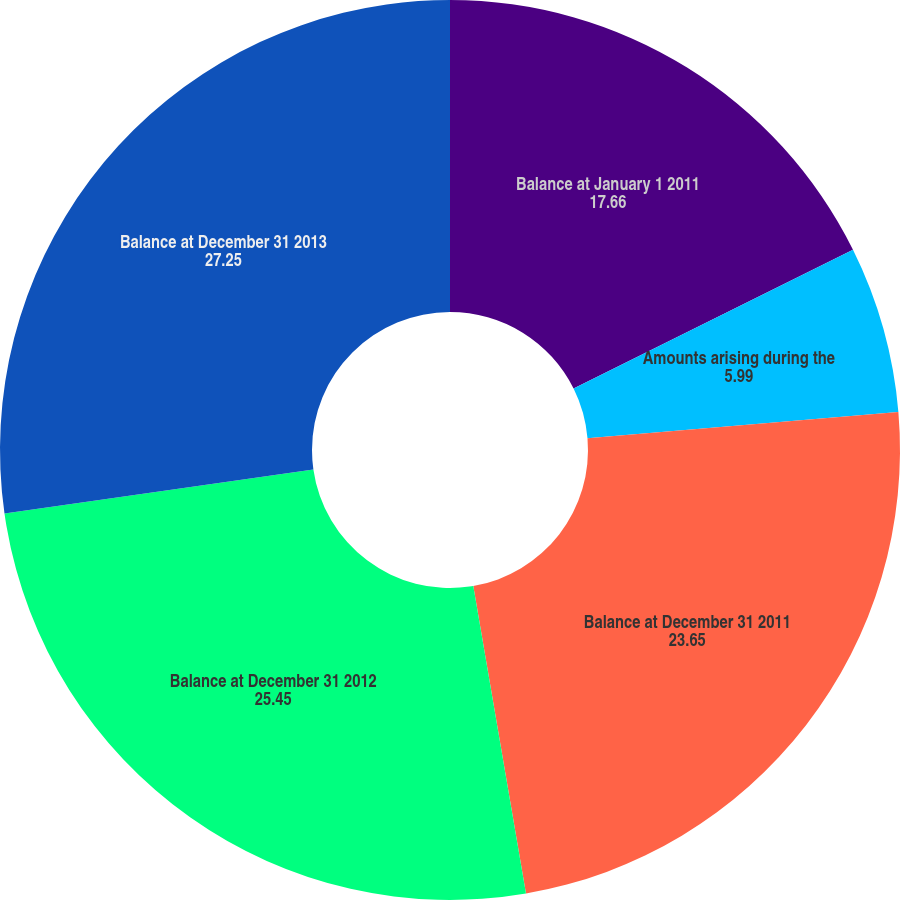<chart> <loc_0><loc_0><loc_500><loc_500><pie_chart><fcel>Balance at January 1 2011<fcel>Amounts arising during the<fcel>Balance at December 31 2011<fcel>Balance at December 31 2012<fcel>Balance at December 31 2013<nl><fcel>17.66%<fcel>5.99%<fcel>23.65%<fcel>25.45%<fcel>27.25%<nl></chart> 